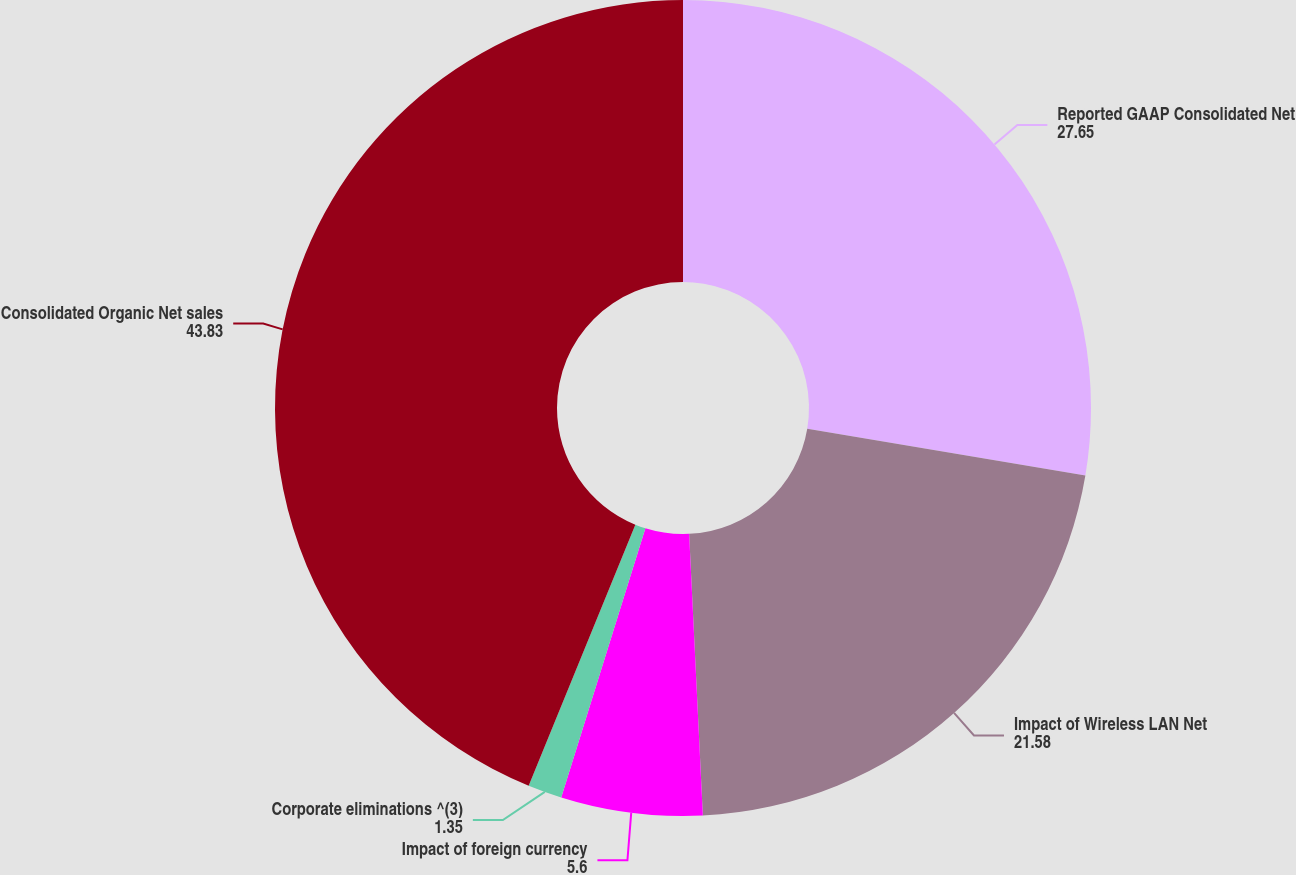Convert chart. <chart><loc_0><loc_0><loc_500><loc_500><pie_chart><fcel>Reported GAAP Consolidated Net<fcel>Impact of Wireless LAN Net<fcel>Impact of foreign currency<fcel>Corporate eliminations ^(3)<fcel>Consolidated Organic Net sales<nl><fcel>27.65%<fcel>21.58%<fcel>5.6%<fcel>1.35%<fcel>43.83%<nl></chart> 